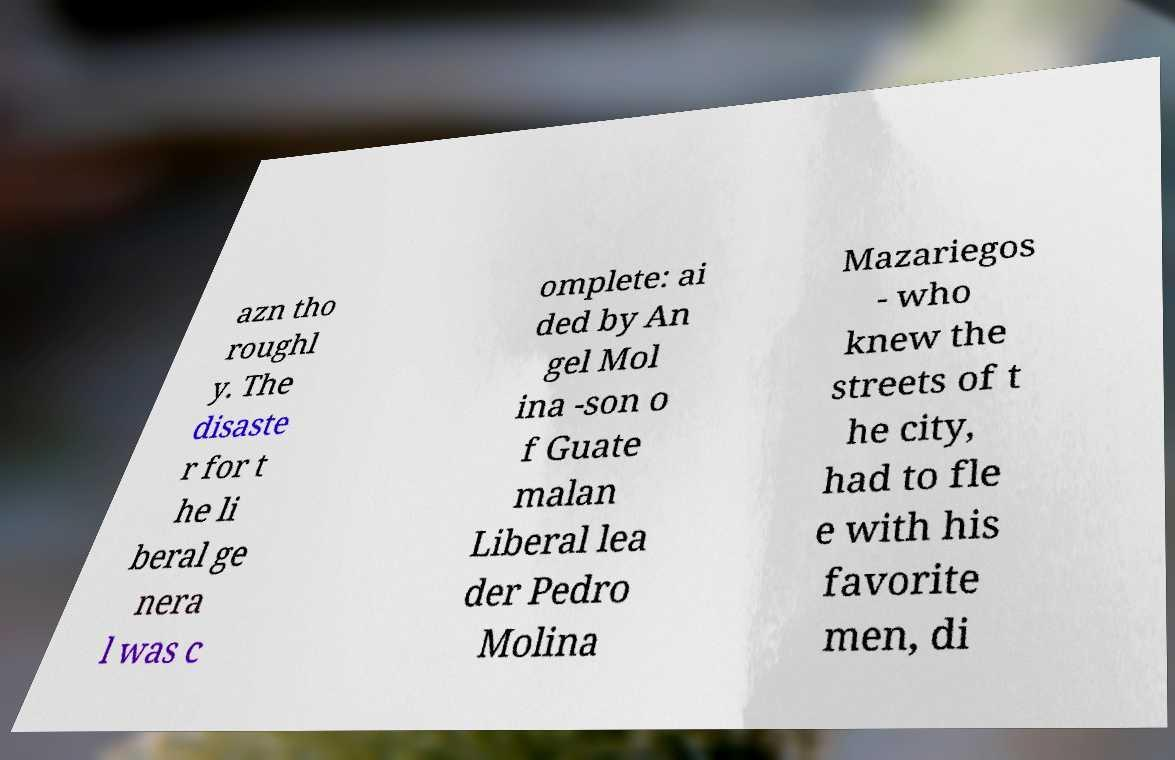Can you accurately transcribe the text from the provided image for me? azn tho roughl y. The disaste r for t he li beral ge nera l was c omplete: ai ded by An gel Mol ina -son o f Guate malan Liberal lea der Pedro Molina Mazariegos - who knew the streets of t he city, had to fle e with his favorite men, di 